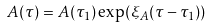Convert formula to latex. <formula><loc_0><loc_0><loc_500><loc_500>A ( \tau ) = A ( \tau _ { 1 } ) \exp ( \xi _ { A } ( \tau - \tau _ { 1 } ) )</formula> 